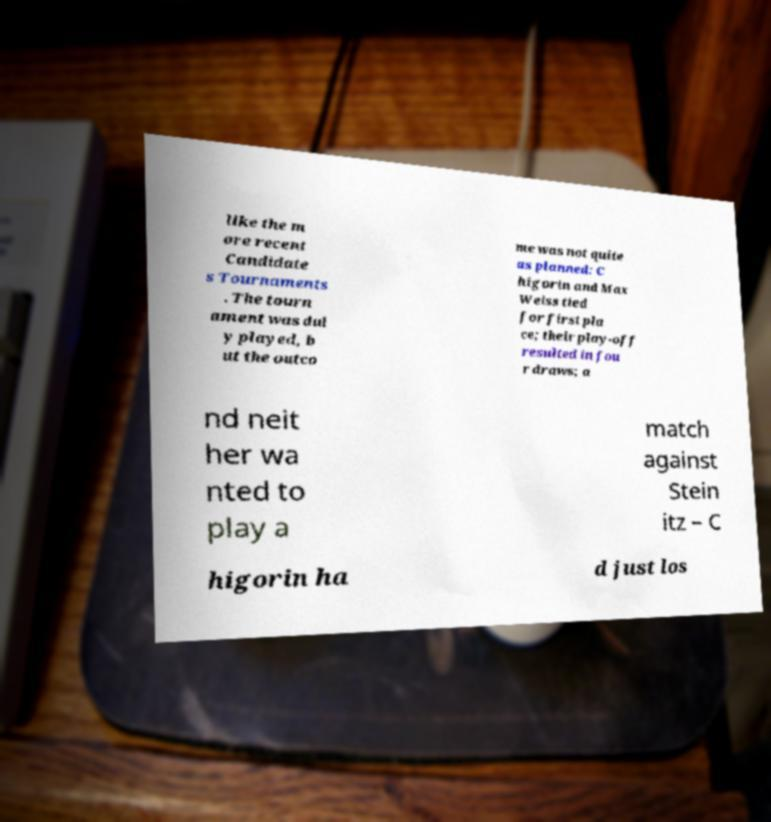For documentation purposes, I need the text within this image transcribed. Could you provide that? like the m ore recent Candidate s Tournaments . The tourn ament was dul y played, b ut the outco me was not quite as planned: C higorin and Max Weiss tied for first pla ce; their play-off resulted in fou r draws; a nd neit her wa nted to play a match against Stein itz – C higorin ha d just los 